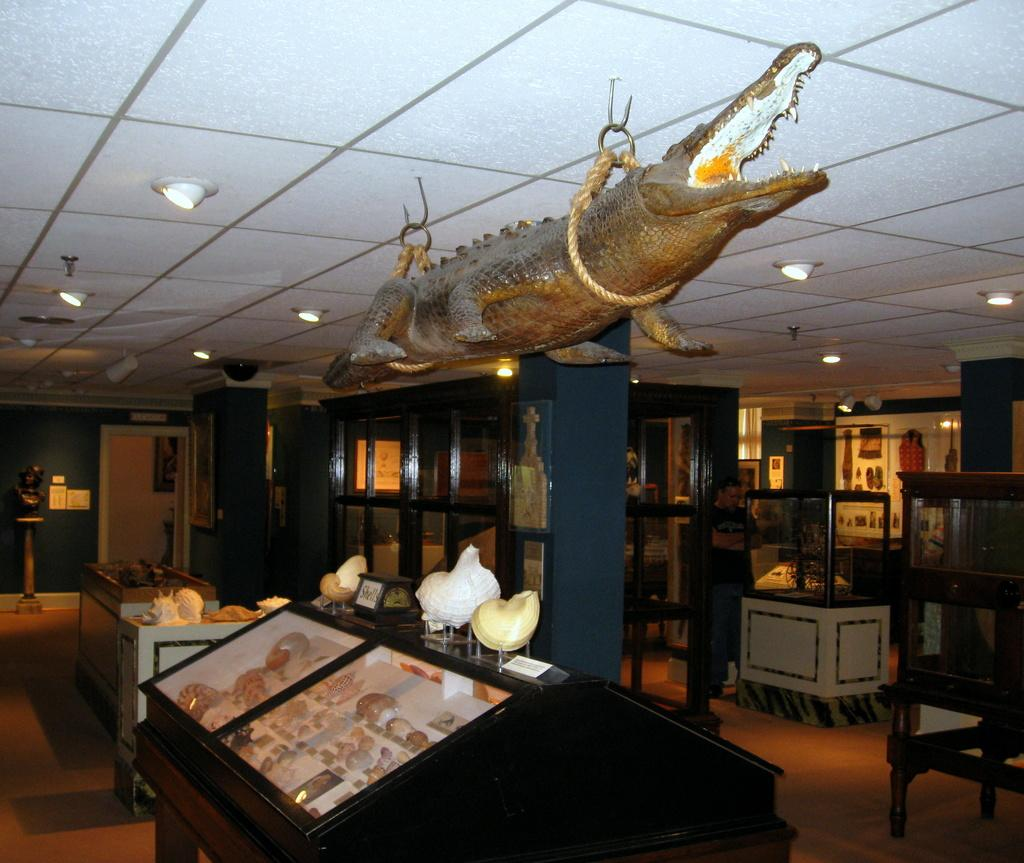What is the main subject of the image? The main subject of the image is a statue of a crocodile. How is the crocodile statue positioned in the image? The crocodile statue is tightened to a rope. Where is the rope attached in relation to the crocodile statue? The rope is attached above the crocodile statue. What can be seen below the crocodile statue in the image? There are other objects below the crocodile statue. What grade of beef is being served in the image? There is no beef present in the image; it features a crocodile statue. What type of soda is being poured into a glass in the image? There is no soda or glass present in the image; it features a crocodile statue and a rope. 